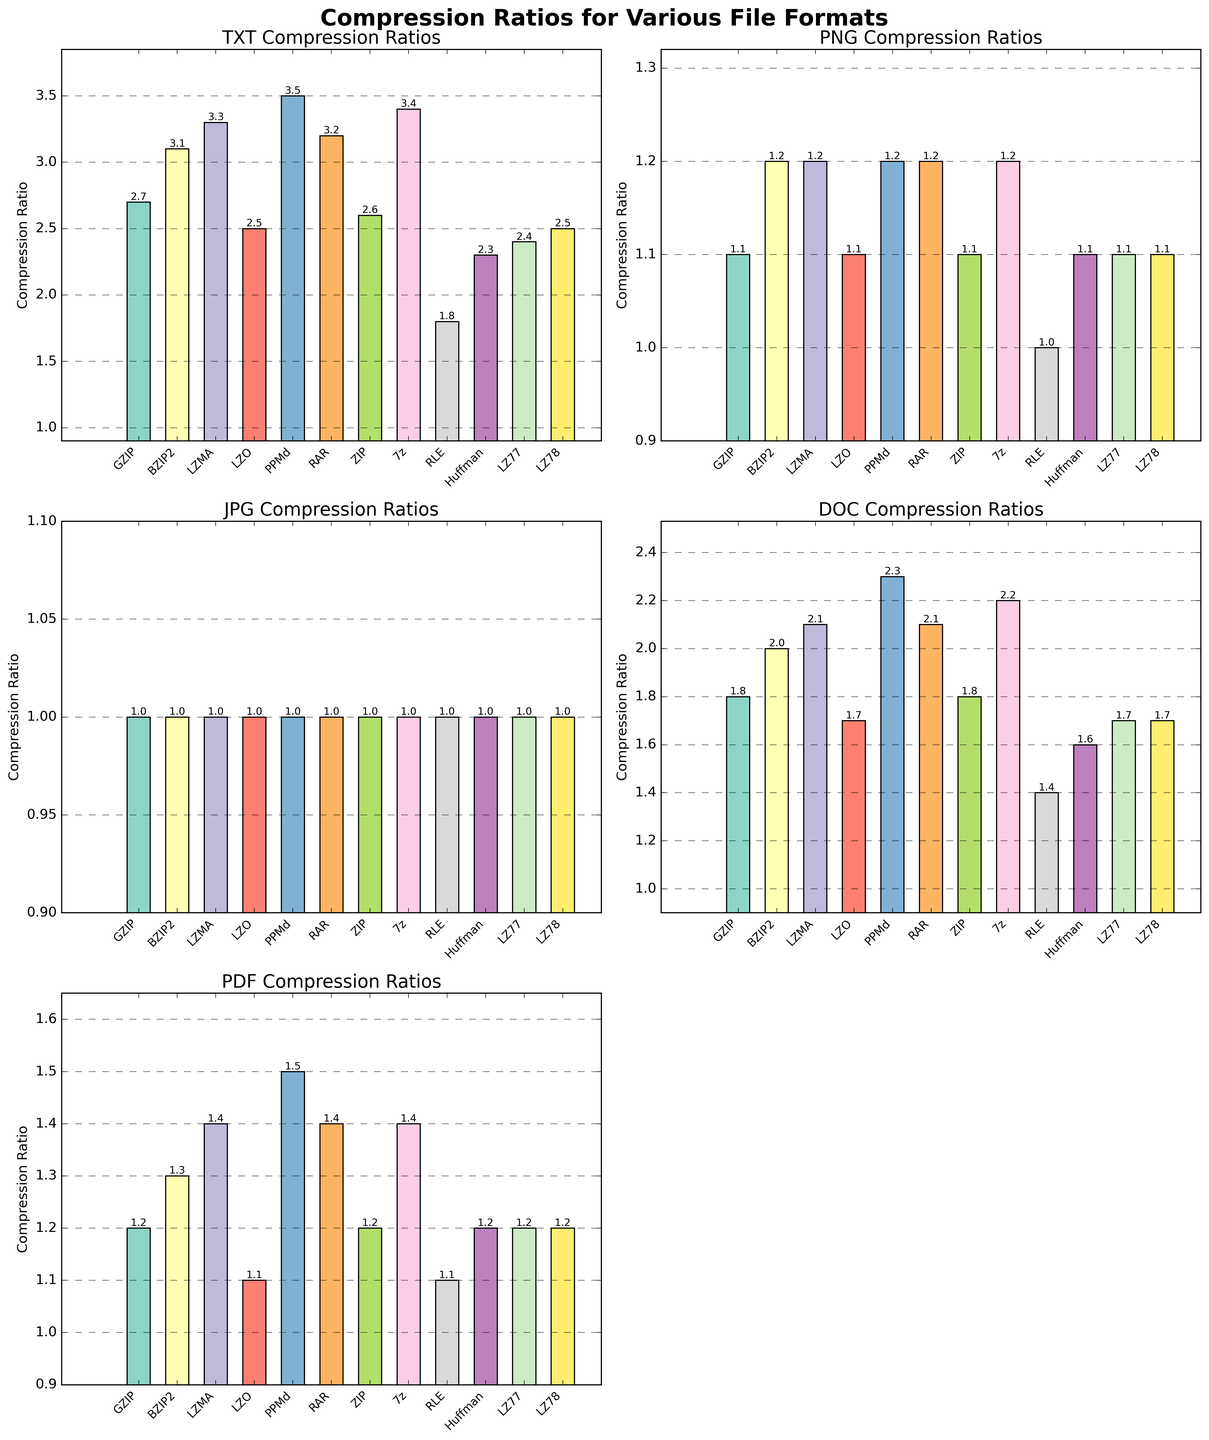Which algorithm achieves the highest compression ratio for TXT files? By examining the bar heights in the subplot for TXT compression ratios, PPMd has the tallest bar among the algorithms.
Answer: PPMd Which file format shows the least compression ratio across all algorithms? By looking at all subplots, JPG compression ratios are constantly at 1.0, which is the lowest across all file formats.
Answer: JPG Which algorithm offers the best overall average compression ratio for DOC files? Calculate the average of the DOC compression ratios for each algorithm. The averages are: GZIP (1.8), BZIP2 (2.0), LZMA (2.1), LZO (1.7), PPMd (2.3), RAR (2.1), ZIP (1.8), 7z (2.2), RLE (1.4), Huffman (1.6), LZ77 (1.7), LZ78 (1.7). PPMd has the highest average at 2.3.
Answer: PPMd Between GZIP and LZMA, which algorithm performs better for compressing PDF files? In the PDF compression ratios subplot, compare the bar heights for GZIP and LZMA. LZMA's bar is taller at 1.4 compared to GZIP at 1.2.
Answer: LZMA What's the highest compression ratio achieved for PNG files and by which algorithm? From the PNG compression ratios subplot, the tallest bar represents a value of 1.2, achieved by multiple algorithms: BZIP2, LZMA, PPMd, RAR, 7z.
Answer: 1.2 by BZIP2, LZMA, PPMd, RAR, 7z Which algorithm has the smallest difference in compression ratios between TXT and DOC files? Calculate the absolute differences for each algorithm: GZIP (2.7-1.8=0.9), BZIP2 (3.1-2.0=1.1), LZMA (3.3-2.1=1.2), LZO (2.5-1.7=0.8), PPMd (3.5-2.3=1.2), RAR (3.2-2.1=1.1), ZIP (2.6-1.8=0.8), 7z (3.4-2.2=1.2), RLE (1.8-1.4=0.4), Huffman (2.3-1.6=0.7), LZ77 (2.4-1.7=0.7), LZ78 (2.5-1.7=0.8). The smallest difference is 0.4 achieved by RLE.
Answer: RLE In which format(s) does LZO perform better than GZIP? Compare the bar heights of LZO against GZIP in each subplot. LZO performs better (higher ratio) than GZIP in none of the formats; it’s equal or worse in every case.
Answer: None 